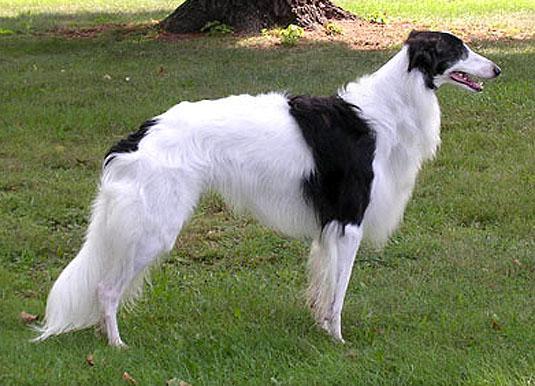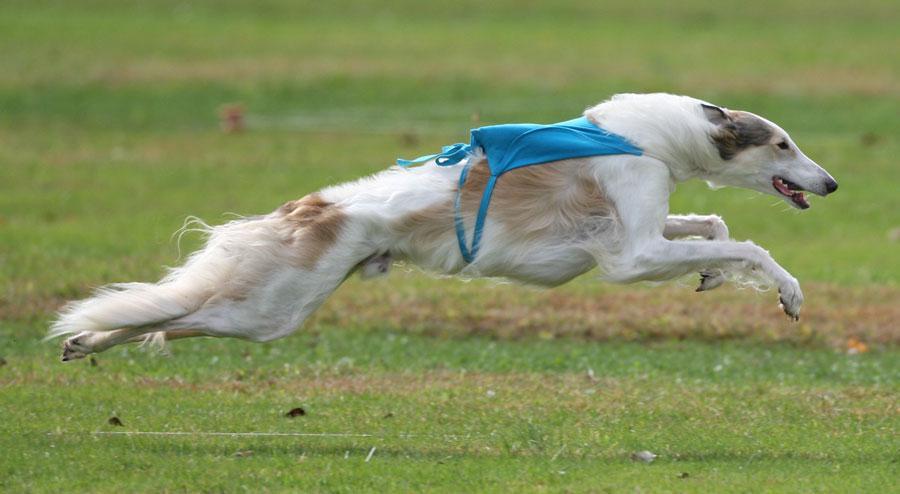The first image is the image on the left, the second image is the image on the right. Given the left and right images, does the statement "An image shows a hound with at least its two front paws fully off the ground." hold true? Answer yes or no. Yes. 